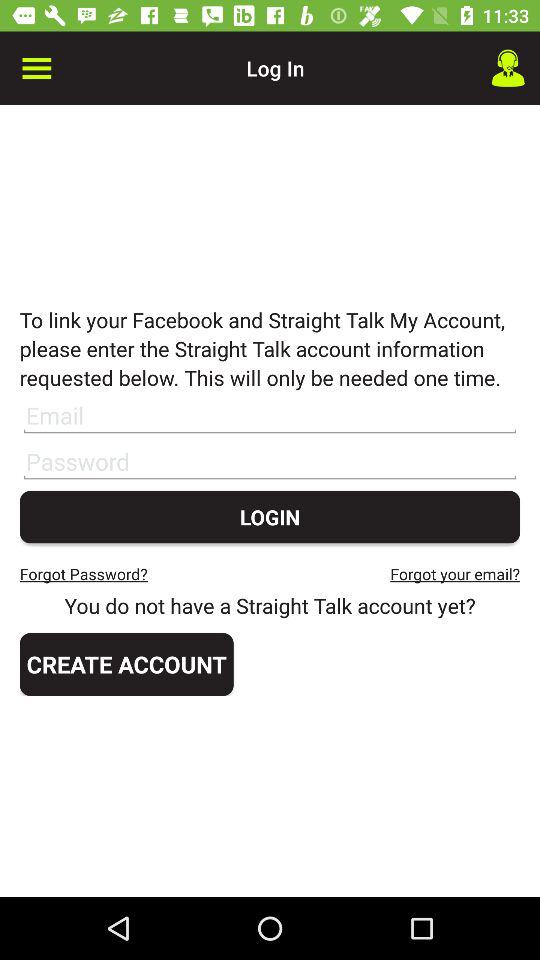Through what application can be linked? The application is "Facebook". 